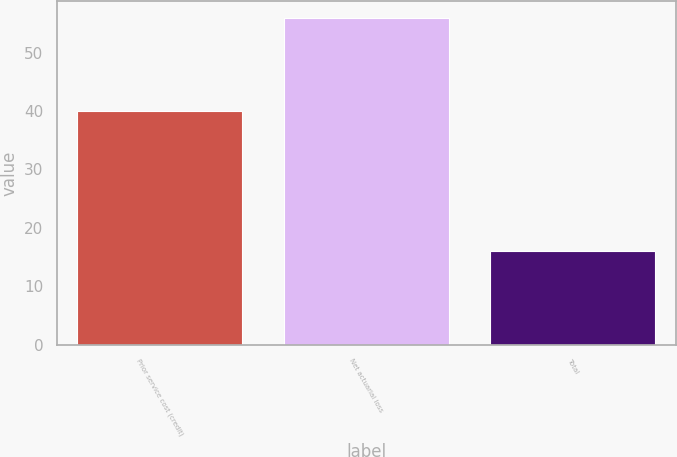<chart> <loc_0><loc_0><loc_500><loc_500><bar_chart><fcel>Prior service cost (credit)<fcel>Net actuarial loss<fcel>Total<nl><fcel>40<fcel>56<fcel>16<nl></chart> 